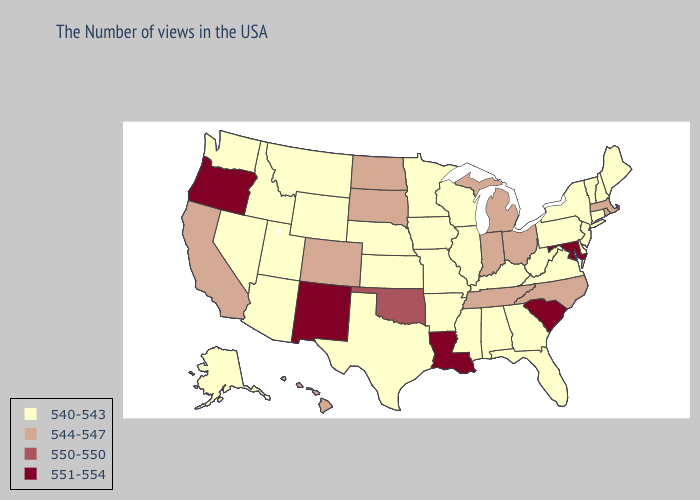Among the states that border Missouri , does Tennessee have the lowest value?
Concise answer only. No. What is the lowest value in the South?
Be succinct. 540-543. Among the states that border Oklahoma , does Texas have the lowest value?
Concise answer only. Yes. Which states have the lowest value in the USA?
Write a very short answer. Maine, New Hampshire, Vermont, Connecticut, New York, New Jersey, Delaware, Pennsylvania, Virginia, West Virginia, Florida, Georgia, Kentucky, Alabama, Wisconsin, Illinois, Mississippi, Missouri, Arkansas, Minnesota, Iowa, Kansas, Nebraska, Texas, Wyoming, Utah, Montana, Arizona, Idaho, Nevada, Washington, Alaska. Name the states that have a value in the range 550-550?
Write a very short answer. Oklahoma. What is the highest value in the MidWest ?
Concise answer only. 544-547. What is the value of Montana?
Concise answer only. 540-543. What is the highest value in states that border Oklahoma?
Keep it brief. 551-554. Does California have the highest value in the USA?
Keep it brief. No. Name the states that have a value in the range 540-543?
Answer briefly. Maine, New Hampshire, Vermont, Connecticut, New York, New Jersey, Delaware, Pennsylvania, Virginia, West Virginia, Florida, Georgia, Kentucky, Alabama, Wisconsin, Illinois, Mississippi, Missouri, Arkansas, Minnesota, Iowa, Kansas, Nebraska, Texas, Wyoming, Utah, Montana, Arizona, Idaho, Nevada, Washington, Alaska. Does the map have missing data?
Short answer required. No. Does the first symbol in the legend represent the smallest category?
Keep it brief. Yes. Name the states that have a value in the range 551-554?
Short answer required. Maryland, South Carolina, Louisiana, New Mexico, Oregon. Does the map have missing data?
Be succinct. No. Name the states that have a value in the range 544-547?
Be succinct. Massachusetts, Rhode Island, North Carolina, Ohio, Michigan, Indiana, Tennessee, South Dakota, North Dakota, Colorado, California, Hawaii. 